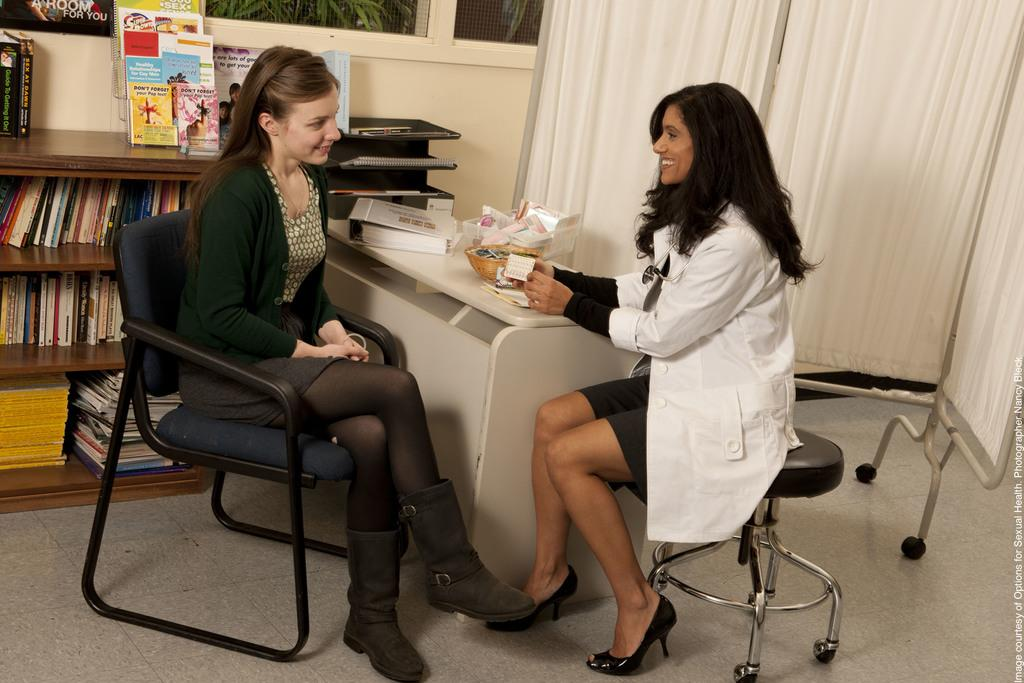What is the position of the woman in the image? There is a woman sitting in a chair. Can you describe the setting of the image? There is another woman sitting in a chair near a table, and there are books in the racks in the background. What can be seen in the background of the image? There is a curtain and plants in the background. What type of corn is being grown in the image? There is no corn present in the image. Can you describe the straw used for the chairs in the image? The chairs in the image do not appear to be made of straw. 